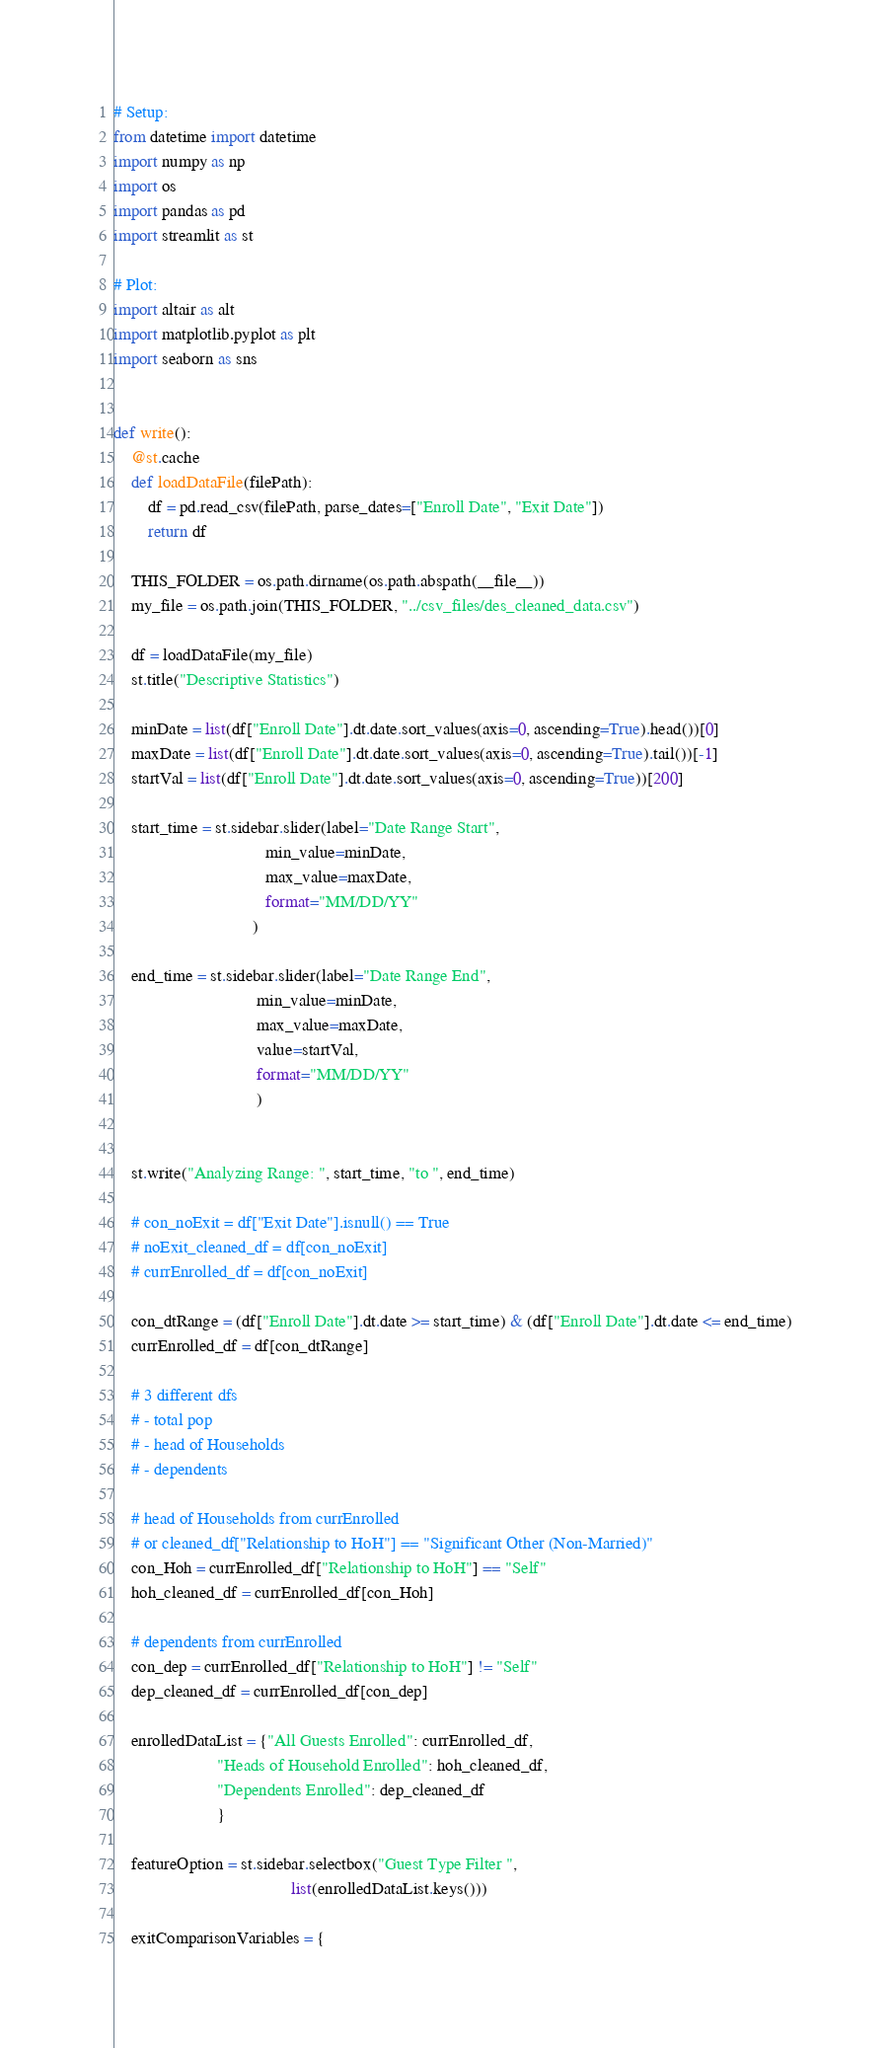<code> <loc_0><loc_0><loc_500><loc_500><_Python_># Setup:
from datetime import datetime
import numpy as np
import os
import pandas as pd
import streamlit as st

# Plot:
import altair as alt
import matplotlib.pyplot as plt
import seaborn as sns


def write():
    @st.cache
    def loadDataFile(filePath):
        df = pd.read_csv(filePath, parse_dates=["Enroll Date", "Exit Date"])
        return df

    THIS_FOLDER = os.path.dirname(os.path.abspath(__file__))
    my_file = os.path.join(THIS_FOLDER, "../csv_files/des_cleaned_data.csv")

    df = loadDataFile(my_file)
    st.title("Descriptive Statistics")

    minDate = list(df["Enroll Date"].dt.date.sort_values(axis=0, ascending=True).head())[0]
    maxDate = list(df["Enroll Date"].dt.date.sort_values(axis=0, ascending=True).tail())[-1]
    startVal = list(df["Enroll Date"].dt.date.sort_values(axis=0, ascending=True))[200]

    start_time = st.sidebar.slider(label="Date Range Start",
                                   min_value=minDate,
                                   max_value=maxDate,
                                   format="MM/DD/YY"
                                )

    end_time = st.sidebar.slider(label="Date Range End",
                                 min_value=minDate,
                                 max_value=maxDate,
                                 value=startVal,
                                 format="MM/DD/YY"
                                 )

    
    st.write("Analyzing Range: ", start_time, "to ", end_time)

    # con_noExit = df["Exit Date"].isnull() == True
    # noExit_cleaned_df = df[con_noExit]
    # currEnrolled_df = df[con_noExit]

    con_dtRange = (df["Enroll Date"].dt.date >= start_time) & (df["Enroll Date"].dt.date <= end_time)
    currEnrolled_df = df[con_dtRange]

    # 3 different dfs
    # - total pop
    # - head of Households
    # - dependents

    # head of Households from currEnrolled
    # or cleaned_df["Relationship to HoH"] == "Significant Other (Non-Married)"
    con_Hoh = currEnrolled_df["Relationship to HoH"] == "Self"
    hoh_cleaned_df = currEnrolled_df[con_Hoh]

    # dependents from currEnrolled
    con_dep = currEnrolled_df["Relationship to HoH"] != "Self"
    dep_cleaned_df = currEnrolled_df[con_dep]

    enrolledDataList = {"All Guests Enrolled": currEnrolled_df,
                        "Heads of Household Enrolled": hoh_cleaned_df,
                        "Dependents Enrolled": dep_cleaned_df
                        }

    featureOption = st.sidebar.selectbox("Guest Type Filter ",
                                         list(enrolledDataList.keys()))

    exitComparisonVariables = {</code> 